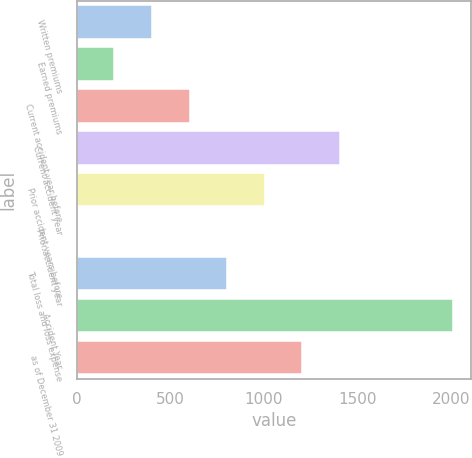Convert chart. <chart><loc_0><loc_0><loc_500><loc_500><bar_chart><fcel>Written premiums<fcel>Earned premiums<fcel>Current accident year before<fcel>Current accident year<fcel>Prior accident years before<fcel>Prior accident year<fcel>Total loss and loss expense<fcel>Accident Year<fcel>as of December 31 2009<nl><fcel>402.52<fcel>201.96<fcel>603.08<fcel>1405.32<fcel>1004.2<fcel>1.4<fcel>803.64<fcel>2007<fcel>1204.76<nl></chart> 